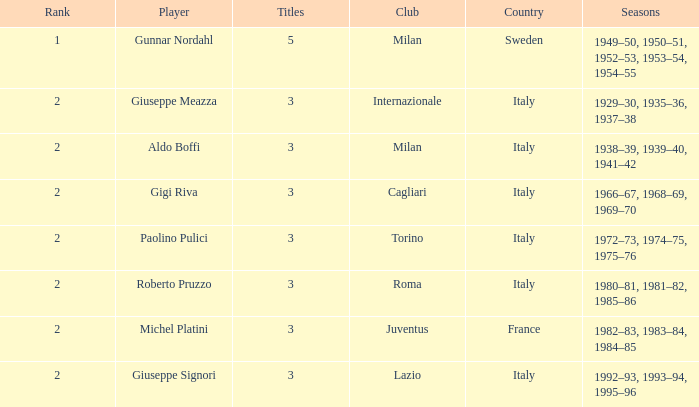What player is ranked 2 and played in the seasons of 1982–83, 1983–84, 1984–85? Michel Platini. 